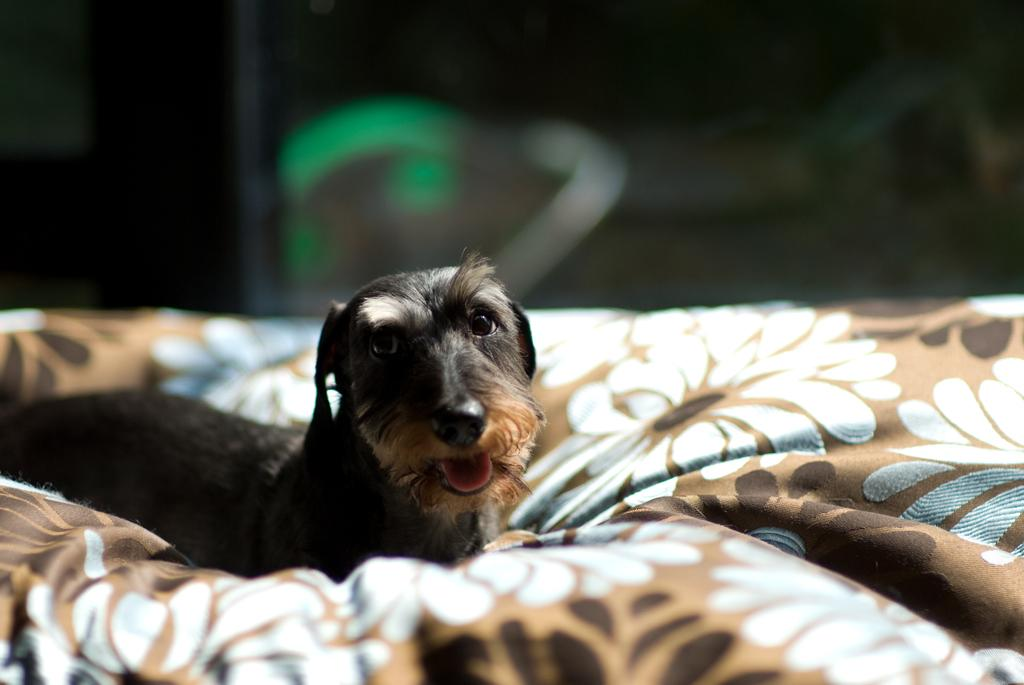What type of animal is in the image? There is a dog in the image. What colors can be seen on the dog? The dog has black and brown coloring. Where is the dog located in the image? The dog is on a blanket. Can you describe the blanket's appearance? The blanket has brown and white coloring. What is the background of the image like? The background of the image is blurred. Is there a mine visible in the image? No, there is no mine present in the image. Can you describe the tail of the squirrel in the image? There is no squirrel present in the image, so it is not possible to describe its tail. 